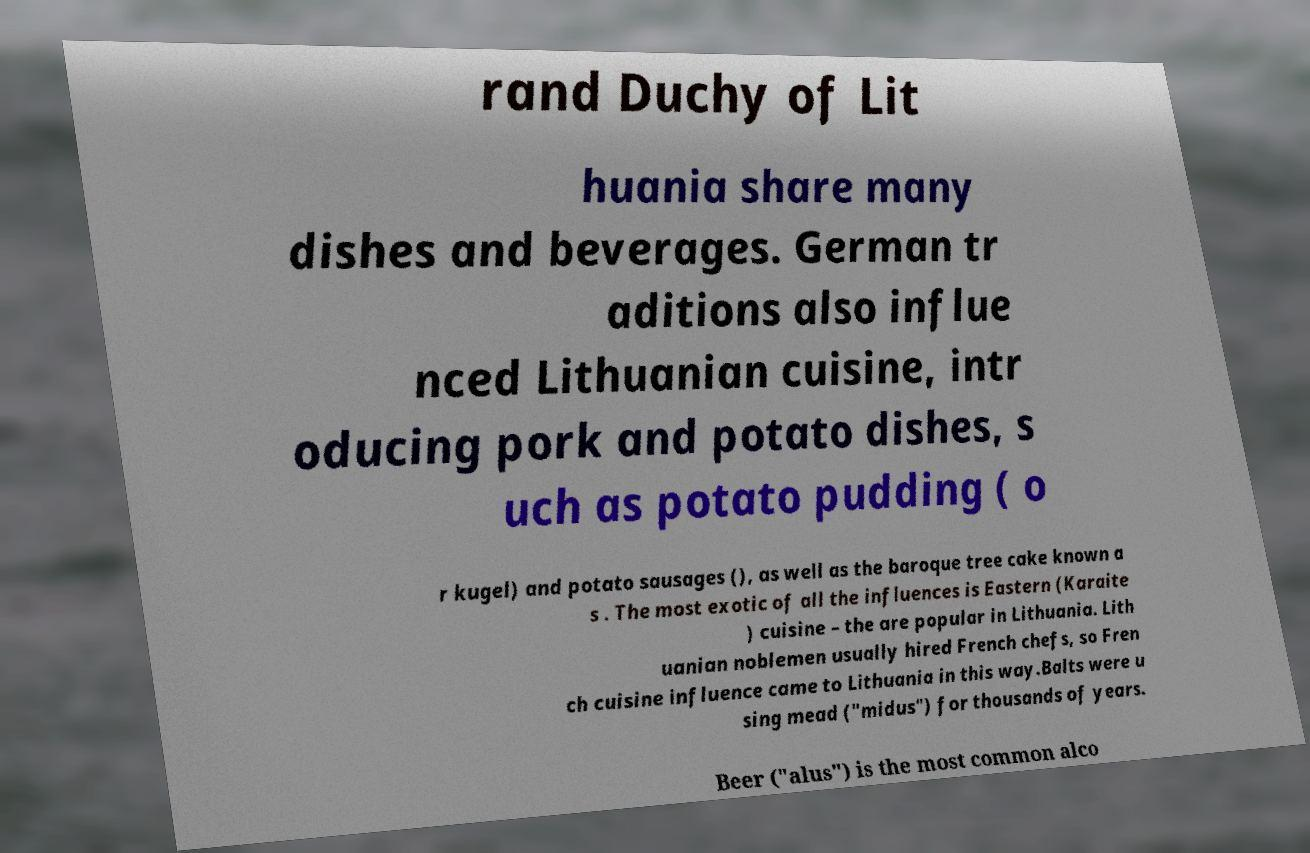For documentation purposes, I need the text within this image transcribed. Could you provide that? rand Duchy of Lit huania share many dishes and beverages. German tr aditions also influe nced Lithuanian cuisine, intr oducing pork and potato dishes, s uch as potato pudding ( o r kugel) and potato sausages (), as well as the baroque tree cake known a s . The most exotic of all the influences is Eastern (Karaite ) cuisine – the are popular in Lithuania. Lith uanian noblemen usually hired French chefs, so Fren ch cuisine influence came to Lithuania in this way.Balts were u sing mead ("midus") for thousands of years. Beer ("alus") is the most common alco 